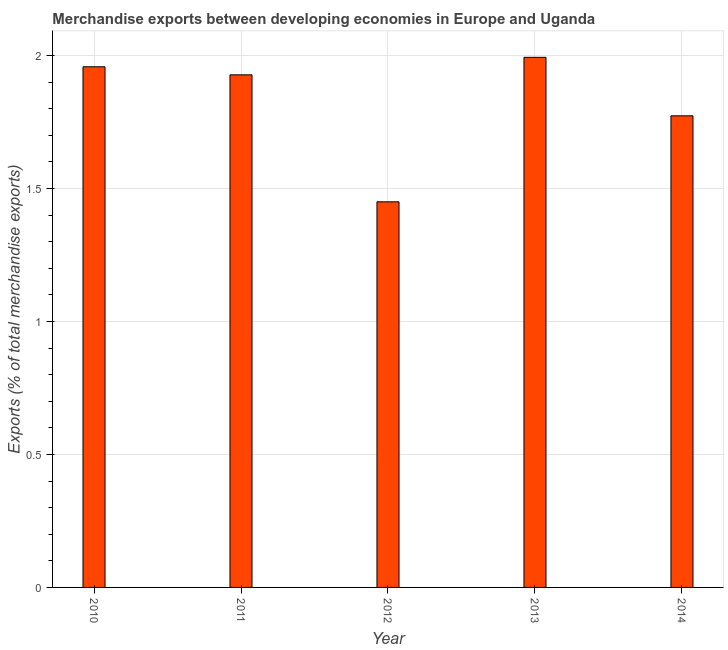Does the graph contain any zero values?
Offer a terse response. No. Does the graph contain grids?
Give a very brief answer. Yes. What is the title of the graph?
Offer a very short reply. Merchandise exports between developing economies in Europe and Uganda. What is the label or title of the Y-axis?
Your answer should be very brief. Exports (% of total merchandise exports). What is the merchandise exports in 2012?
Make the answer very short. 1.45. Across all years, what is the maximum merchandise exports?
Give a very brief answer. 1.99. Across all years, what is the minimum merchandise exports?
Offer a very short reply. 1.45. In which year was the merchandise exports maximum?
Offer a very short reply. 2013. In which year was the merchandise exports minimum?
Your answer should be very brief. 2012. What is the sum of the merchandise exports?
Your response must be concise. 9.1. What is the difference between the merchandise exports in 2012 and 2014?
Ensure brevity in your answer.  -0.32. What is the average merchandise exports per year?
Make the answer very short. 1.82. What is the median merchandise exports?
Your answer should be compact. 1.93. In how many years, is the merchandise exports greater than 1 %?
Offer a very short reply. 5. Do a majority of the years between 2011 and 2012 (inclusive) have merchandise exports greater than 1.9 %?
Offer a very short reply. No. What is the ratio of the merchandise exports in 2010 to that in 2011?
Give a very brief answer. 1.02. Is the merchandise exports in 2013 less than that in 2014?
Provide a short and direct response. No. Is the difference between the merchandise exports in 2011 and 2012 greater than the difference between any two years?
Ensure brevity in your answer.  No. What is the difference between the highest and the second highest merchandise exports?
Your answer should be compact. 0.04. What is the difference between the highest and the lowest merchandise exports?
Give a very brief answer. 0.54. How many bars are there?
Offer a terse response. 5. Are all the bars in the graph horizontal?
Offer a terse response. No. What is the difference between two consecutive major ticks on the Y-axis?
Provide a short and direct response. 0.5. What is the Exports (% of total merchandise exports) of 2010?
Offer a terse response. 1.96. What is the Exports (% of total merchandise exports) of 2011?
Ensure brevity in your answer.  1.93. What is the Exports (% of total merchandise exports) in 2012?
Your response must be concise. 1.45. What is the Exports (% of total merchandise exports) of 2013?
Your response must be concise. 1.99. What is the Exports (% of total merchandise exports) in 2014?
Ensure brevity in your answer.  1.77. What is the difference between the Exports (% of total merchandise exports) in 2010 and 2011?
Provide a short and direct response. 0.03. What is the difference between the Exports (% of total merchandise exports) in 2010 and 2012?
Your answer should be very brief. 0.51. What is the difference between the Exports (% of total merchandise exports) in 2010 and 2013?
Keep it short and to the point. -0.04. What is the difference between the Exports (% of total merchandise exports) in 2010 and 2014?
Provide a succinct answer. 0.18. What is the difference between the Exports (% of total merchandise exports) in 2011 and 2012?
Offer a very short reply. 0.48. What is the difference between the Exports (% of total merchandise exports) in 2011 and 2013?
Ensure brevity in your answer.  -0.07. What is the difference between the Exports (% of total merchandise exports) in 2011 and 2014?
Provide a short and direct response. 0.15. What is the difference between the Exports (% of total merchandise exports) in 2012 and 2013?
Your answer should be very brief. -0.54. What is the difference between the Exports (% of total merchandise exports) in 2012 and 2014?
Offer a terse response. -0.32. What is the difference between the Exports (% of total merchandise exports) in 2013 and 2014?
Ensure brevity in your answer.  0.22. What is the ratio of the Exports (% of total merchandise exports) in 2010 to that in 2012?
Your answer should be very brief. 1.35. What is the ratio of the Exports (% of total merchandise exports) in 2010 to that in 2013?
Provide a succinct answer. 0.98. What is the ratio of the Exports (% of total merchandise exports) in 2010 to that in 2014?
Make the answer very short. 1.1. What is the ratio of the Exports (% of total merchandise exports) in 2011 to that in 2012?
Your answer should be compact. 1.33. What is the ratio of the Exports (% of total merchandise exports) in 2011 to that in 2014?
Keep it short and to the point. 1.09. What is the ratio of the Exports (% of total merchandise exports) in 2012 to that in 2013?
Provide a short and direct response. 0.73. What is the ratio of the Exports (% of total merchandise exports) in 2012 to that in 2014?
Give a very brief answer. 0.82. What is the ratio of the Exports (% of total merchandise exports) in 2013 to that in 2014?
Offer a very short reply. 1.12. 